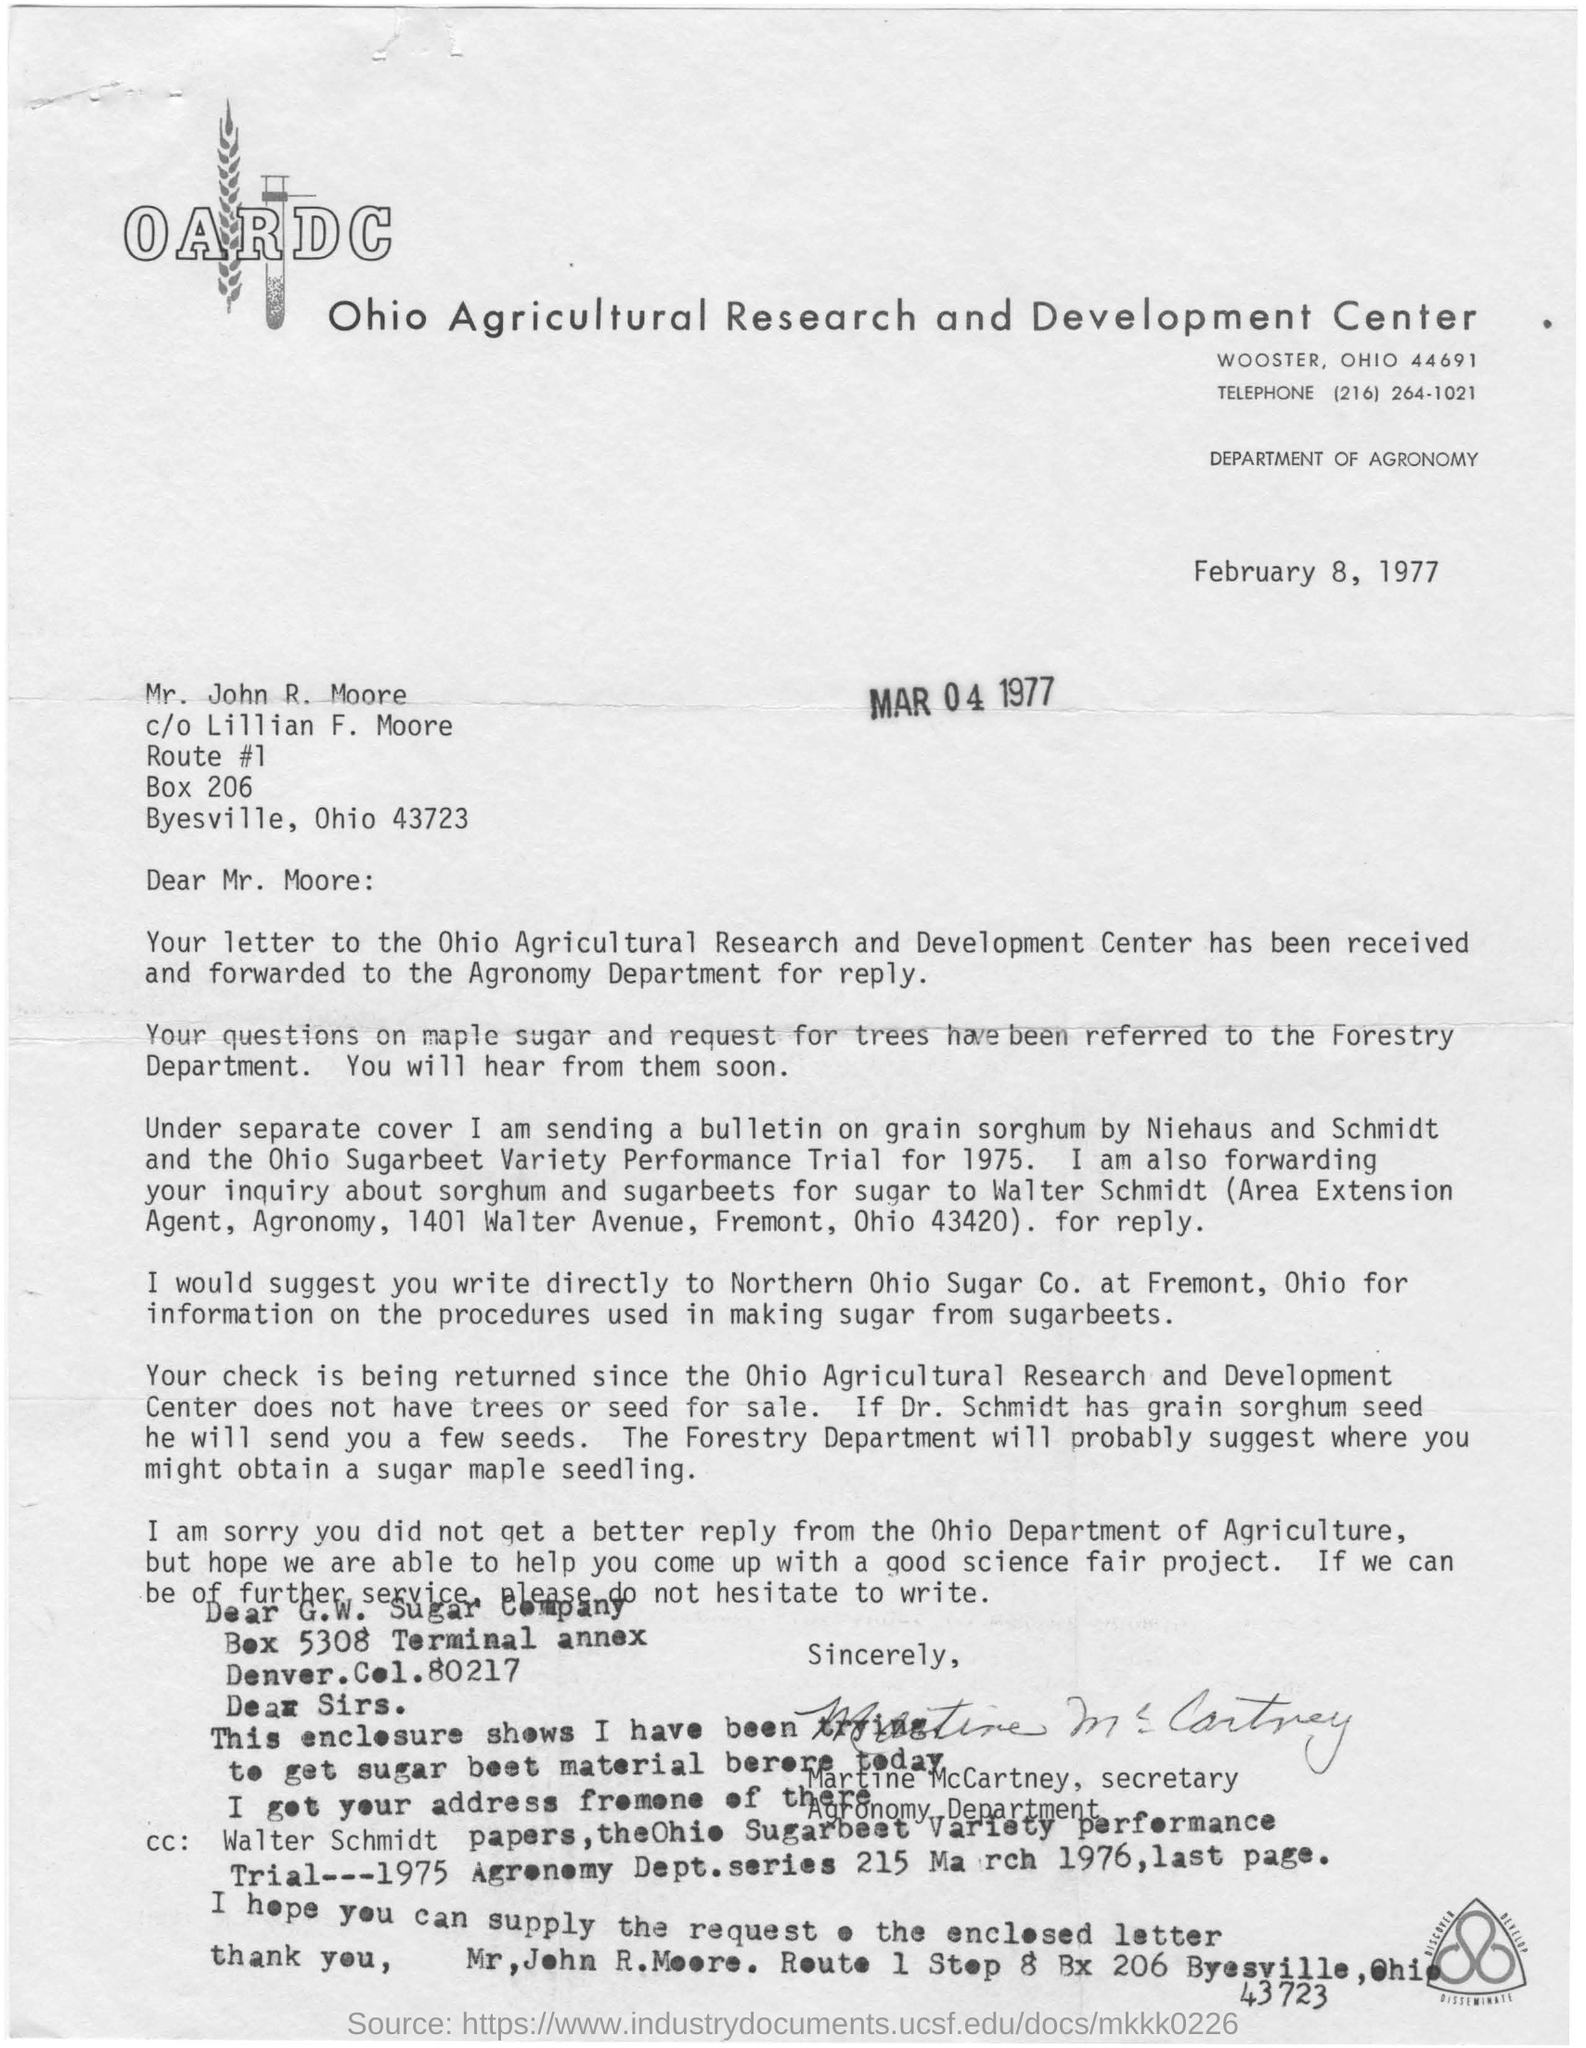List a handful of essential elements in this visual. OARDC, or the Ohio Agricultural Research and Development Center, is a research center dedicated to advancing the understanding and improvement of agriculture in the state of Ohio. 